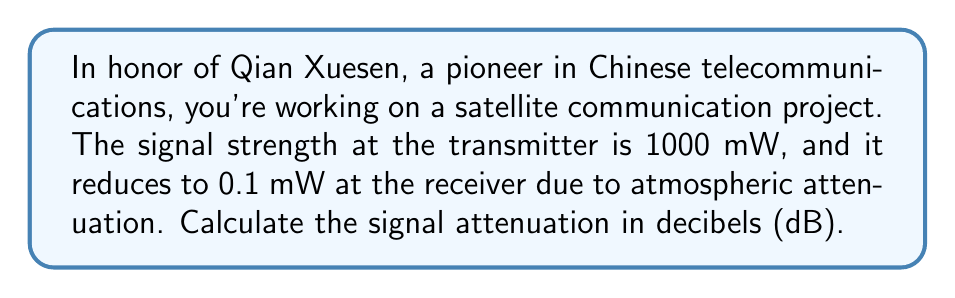Can you solve this math problem? To solve this problem, we'll use the formula for calculating attenuation in decibels:

$$ \text{Attenuation (dB)} = 10 \log_{10}\left(\frac{P_1}{P_2}\right) $$

Where:
$P_1$ is the input power (at the transmitter)
$P_2$ is the output power (at the receiver)

Given:
$P_1 = 1000 \text{ mW}$
$P_2 = 0.1 \text{ mW}$

Step 1: Substitute the values into the formula:

$$ \text{Attenuation (dB)} = 10 \log_{10}\left(\frac{1000 \text{ mW}}{0.1 \text{ mW}}\right) $$

Step 2: Simplify the fraction inside the logarithm:

$$ \text{Attenuation (dB)} = 10 \log_{10}(10000) $$

Step 3: Calculate the logarithm:

$$ \text{Attenuation (dB)} = 10 \cdot 4 = 40 $$

Therefore, the signal attenuation is 40 dB.
Answer: 40 dB 